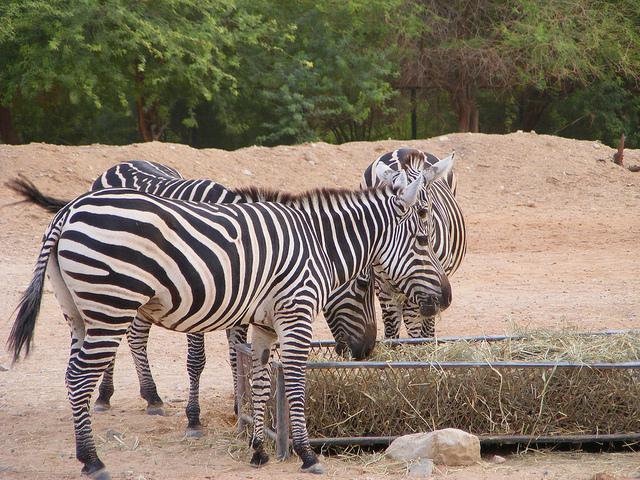Are the zebras in the wild?
Give a very brief answer. No. What color is the trough?
Quick response, please. Silver. What is the zebra standing next to?
Answer briefly. Food. How many zebras are there?
Quick response, please. 3. What are the lines going across the front of the picture?
Answer briefly. Zebra stripes. How many animals in the picture?
Answer briefly. 3. How is the animal fed?
Short answer required. Hay. What is the zebra eating?
Short answer required. Hay. Are these zebras eating?
Keep it brief. Yes. What direction are the zebras facing?
Write a very short answer. Right. Are these zebras fully grown?
Give a very brief answer. Yes. How many zebras are drinking?
Concise answer only. 3. Could this be in the wild?
Answer briefly. No. How many animals are in this picture?
Keep it brief. 3. Are they in the wild?
Be succinct. No. What are the zebras eating?
Keep it brief. Grass. Is this animal contained?
Keep it brief. Yes. 